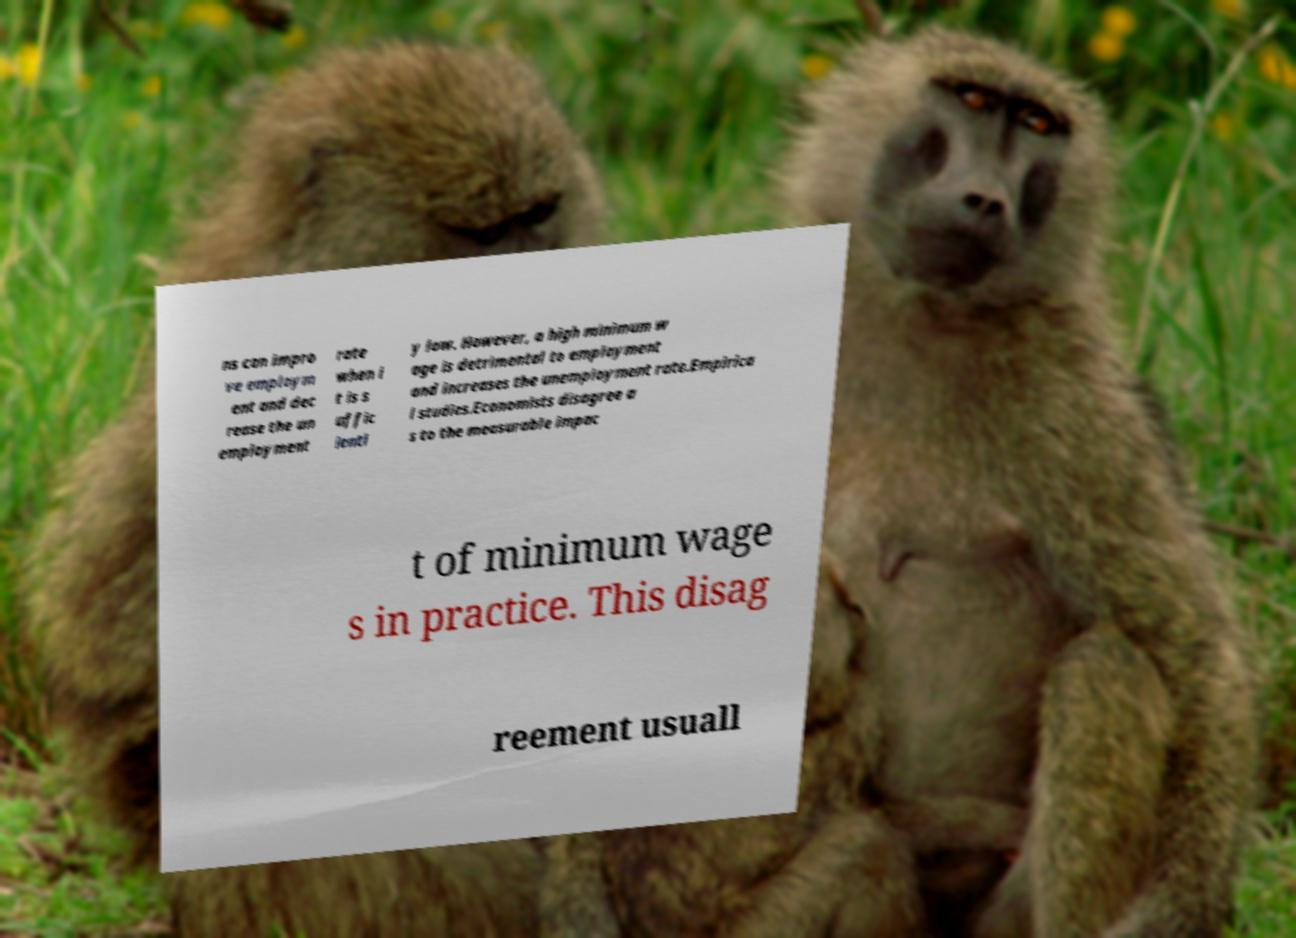I need the written content from this picture converted into text. Can you do that? ns can impro ve employm ent and dec rease the un employment rate when i t is s uffic ientl y low. However, a high minimum w age is detrimental to employment and increases the unemployment rate.Empirica l studies.Economists disagree a s to the measurable impac t of minimum wage s in practice. This disag reement usuall 